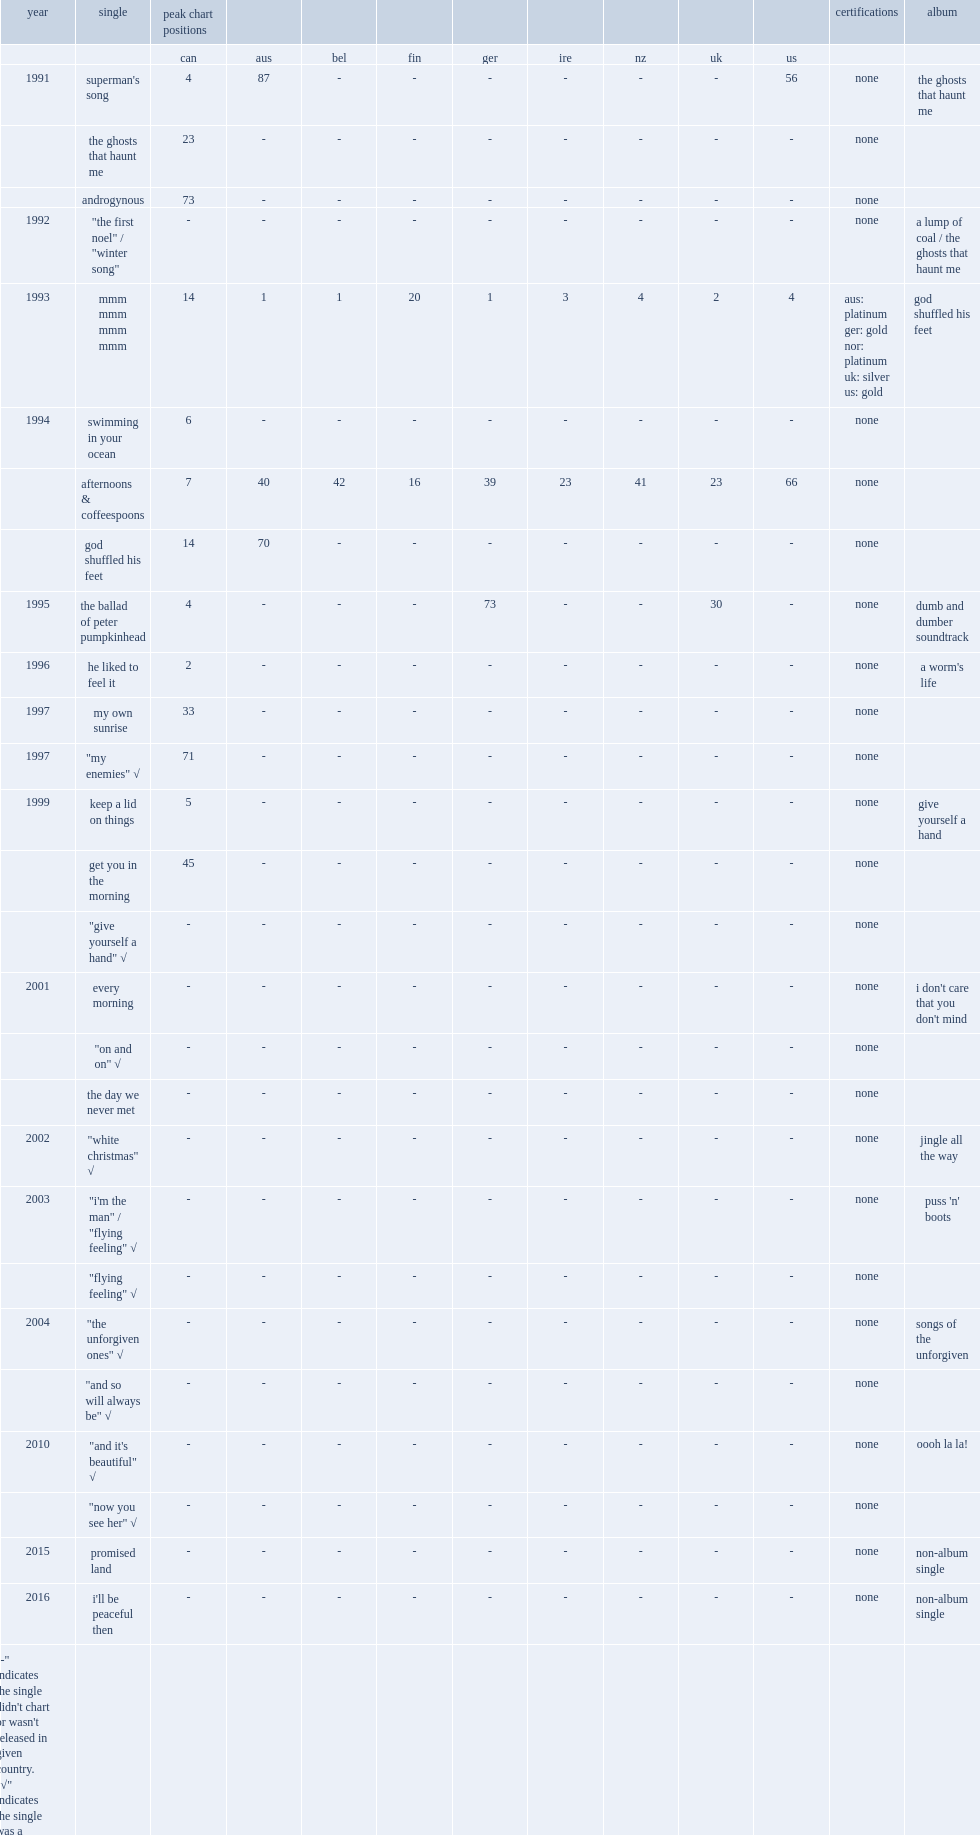Give me the full table as a dictionary. {'header': ['year', 'single', 'peak chart positions', '', '', '', '', '', '', '', '', 'certifications', 'album'], 'rows': [['', '', 'can', 'aus', 'bel', 'fin', 'ger', 'ire', 'nz', 'uk', 'us', '', ''], ['1991', "superman's song", '4', '87', '-', '-', '-', '-', '-', '-', '56', 'none', 'the ghosts that haunt me'], ['', 'the ghosts that haunt me', '23', '-', '-', '-', '-', '-', '-', '-', '-', 'none', ''], ['', 'androgynous', '73', '-', '-', '-', '-', '-', '-', '-', '-', 'none', ''], ['1992', '"the first noel" / "winter song"', '-', '-', '-', '-', '-', '-', '-', '-', '-', 'none', 'a lump of coal / the ghosts that haunt me'], ['1993', 'mmm mmm mmm mmm', '14', '1', '1', '20', '1', '3', '4', '2', '4', 'aus: platinum ger: gold nor: platinum uk: silver us: gold', 'god shuffled his feet'], ['1994', 'swimming in your ocean', '6', '-', '-', '-', '-', '-', '-', '-', '-', 'none', ''], ['', 'afternoons & coffeespoons', '7', '40', '42', '16', '39', '23', '41', '23', '66', 'none', ''], ['', 'god shuffled his feet', '14', '70', '-', '-', '-', '-', '-', '-', '-', 'none', ''], ['1995', 'the ballad of peter pumpkinhead', '4', '-', '-', '-', '73', '-', '-', '30', '-', 'none', 'dumb and dumber soundtrack'], ['1996', 'he liked to feel it', '2', '-', '-', '-', '-', '-', '-', '-', '-', 'none', "a worm's life"], ['1997', 'my own sunrise', '33', '-', '-', '-', '-', '-', '-', '-', '-', 'none', ''], ['1997', '"my enemies" √', '71', '-', '-', '-', '-', '-', '-', '-', '-', 'none', ''], ['1999', 'keep a lid on things', '5', '-', '-', '-', '-', '-', '-', '-', '-', 'none', 'give yourself a hand'], ['', 'get you in the morning', '45', '-', '-', '-', '-', '-', '-', '-', '-', 'none', ''], ['', '"give yourself a hand" √', '-', '-', '-', '-', '-', '-', '-', '-', '-', 'none', ''], ['2001', 'every morning', '-', '-', '-', '-', '-', '-', '-', '-', '-', 'none', "i don't care that you don't mind"], ['', '"on and on" √', '-', '-', '-', '-', '-', '-', '-', '-', '-', 'none', ''], ['', 'the day we never met', '-', '-', '-', '-', '-', '-', '-', '-', '-', 'none', ''], ['2002', '"white christmas" √', '-', '-', '-', '-', '-', '-', '-', '-', '-', 'none', 'jingle all the way'], ['2003', '"i\'m the man" / "flying feeling" √', '-', '-', '-', '-', '-', '-', '-', '-', '-', 'none', "puss 'n' boots"], ['', '"flying feeling" √', '-', '-', '-', '-', '-', '-', '-', '-', '-', 'none', ''], ['2004', '"the unforgiven ones" √', '-', '-', '-', '-', '-', '-', '-', '-', '-', 'none', 'songs of the unforgiven'], ['', '"and so will always be" √', '-', '-', '-', '-', '-', '-', '-', '-', '-', 'none', ''], ['2010', '"and it\'s beautiful" √', '-', '-', '-', '-', '-', '-', '-', '-', '-', 'none', 'oooh la la!'], ['', '"now you see her" √', '-', '-', '-', '-', '-', '-', '-', '-', '-', 'none', ''], ['2015', 'promised land', '-', '-', '-', '-', '-', '-', '-', '-', '-', 'none', 'non-album single'], ['2016', "i'll be peaceful then", '-', '-', '-', '-', '-', '-', '-', '-', '-', 'none', 'non-album single'], ['"-" indicates the single didn\'t chart or wasn\'t released in given country. "√" indicates the single was a promotional-only release', '', '', '', '', '', '', '', '', '', '', '', '']]} When did the single "keep a lid on things" release? 1999.0. 